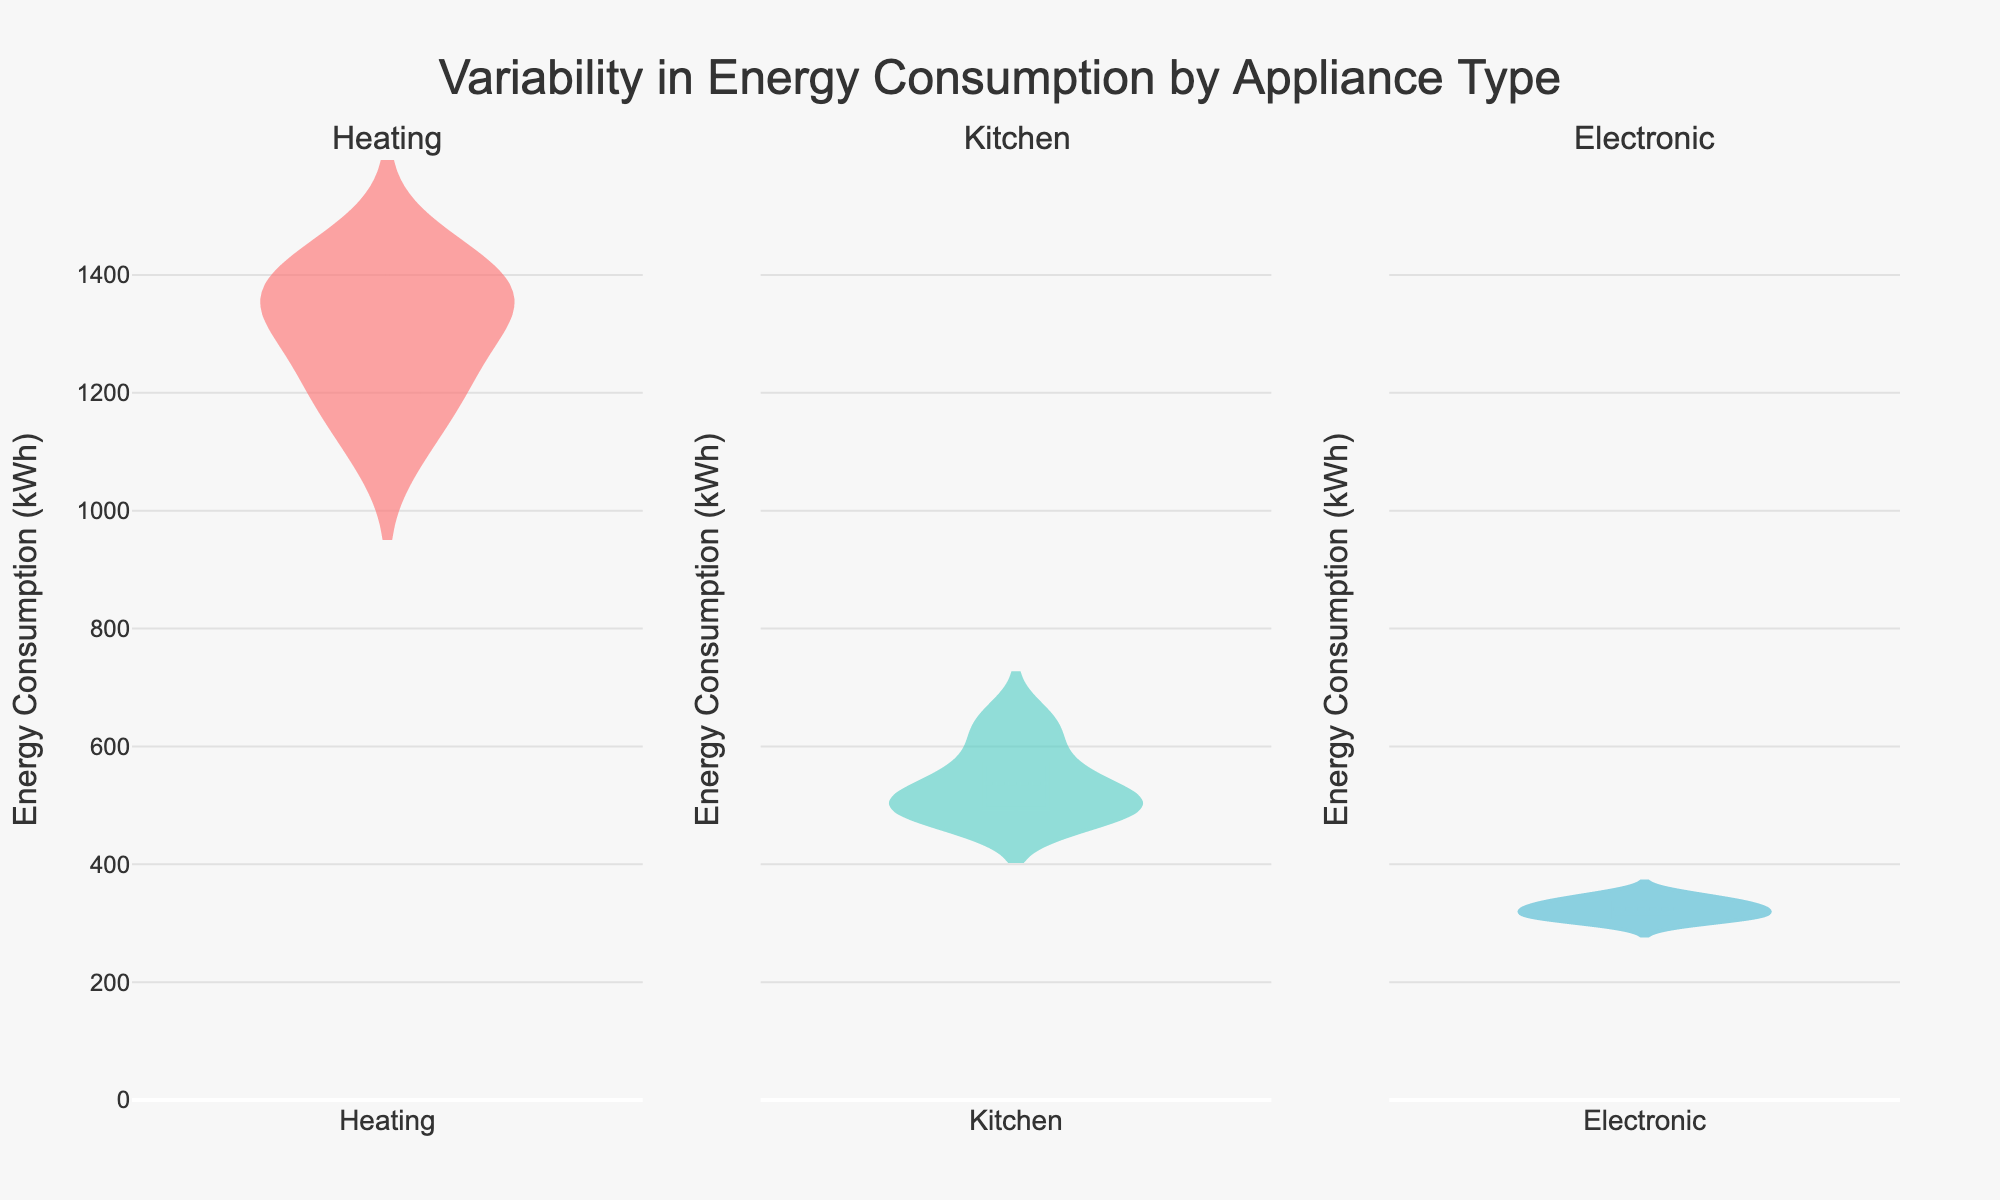What is the title of the figure? The title is typically located at the top center of the plot, describing what the figure is about.
Answer: Variability in Energy Consumption by Appliance Type What are the x-axis labels for the subplots? The x-axis labels represent each appliance type being analyzed.
Answer: Heating, Kitchen, Electronic Which appliance type shows the highest overall energy consumption? We need to observe which plot has the highest values on the y-axis.
Answer: Heating Which appliance type has the smallest range of energy consumption values? We need to look at the spread (or width) of the violin plot, which represents the distribution of the values.
Answer: Electronic How does the average energy consumption for heating compare to kitchen appliances? The average energy consumption can be found using the horizontal line inside the violin plots. Compare the mean lines of Heating and Kitchen.
Answer: Heating is higher Among the different appliance types, which one has the most balanced distribution of energy consumption? Look for the violin plot with the most symmetric shape around its mean line.
Answer: Electronic Compare the energy consumption variability between kitchen and electronic appliances. Variability is indicated by the width and spread of the violin plots. Compare the plots for Kitchen and Electronic.
Answer: Kitchen has more variability What is the approximate maximum energy consumption observed for any kitchen appliance? Look for the highest point on the y-axis within the Kitchen subplot.
Answer: ~650 kWh Which appliance has the least outlier points in its distribution? Outliers are shown as points outside the main body of the violin plot. Identify the subplot with the fewest outliers.
Answer: Electronic What conclusions can you draw about the energy consumption pattern of heating appliances? Summarize observations like high average consumption, large range, etc.
Answer: High average consumption, larger range, more outliers 